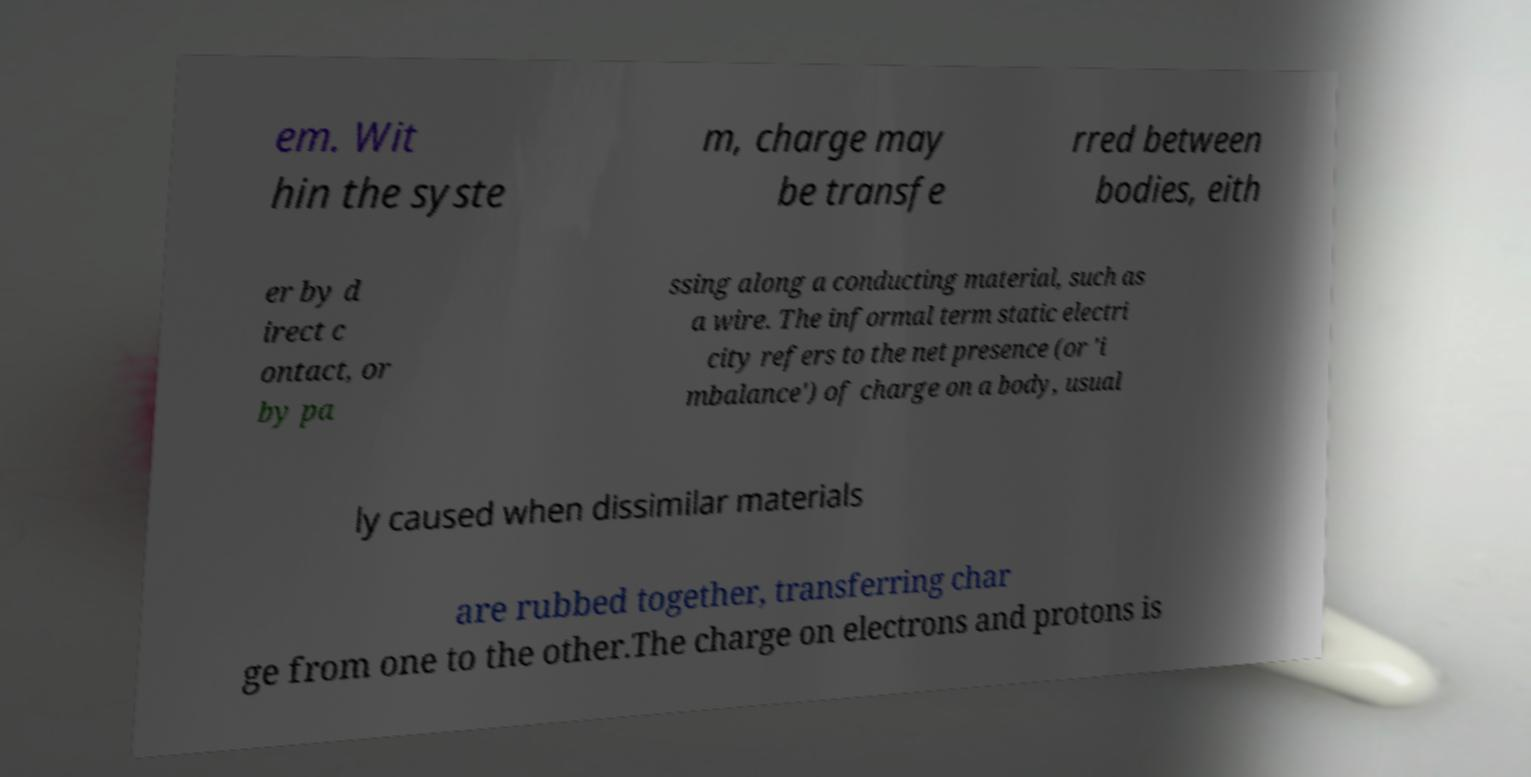I need the written content from this picture converted into text. Can you do that? em. Wit hin the syste m, charge may be transfe rred between bodies, eith er by d irect c ontact, or by pa ssing along a conducting material, such as a wire. The informal term static electri city refers to the net presence (or 'i mbalance') of charge on a body, usual ly caused when dissimilar materials are rubbed together, transferring char ge from one to the other.The charge on electrons and protons is 